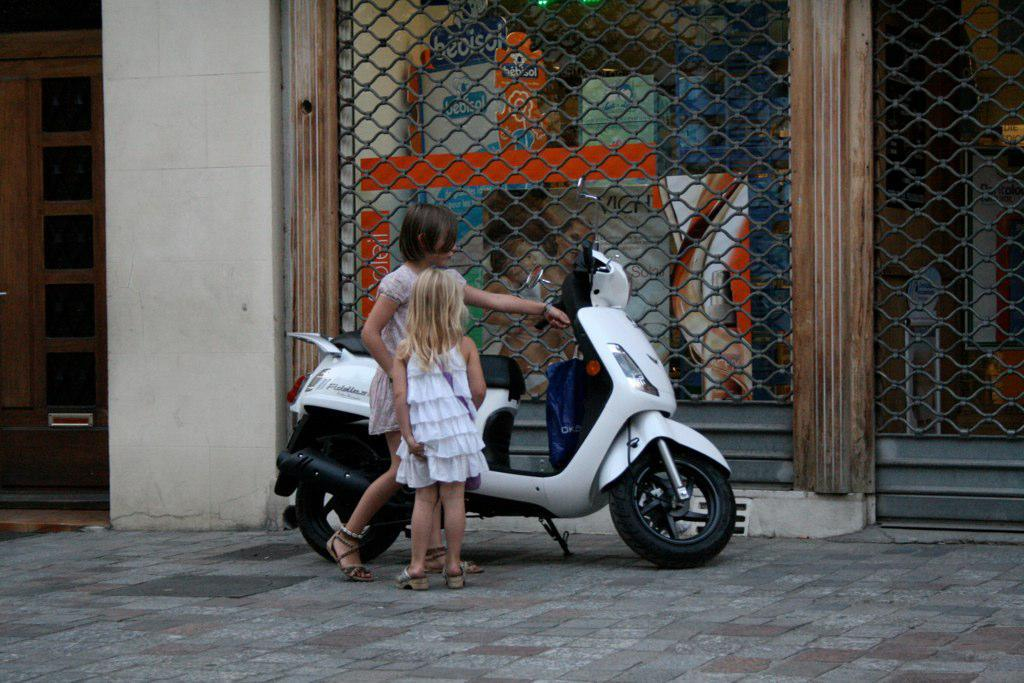What is the main subject of the image? There is a vehicle in the image. Can you describe the people in the image? There are two girls on the ground in the image. What can be seen in the background of the image? There is a poster visible in the background of the image. What type of prison can be seen in the image? There is no prison present in the image. What story are the girls telling each other in the image? The image does not provide any information about a story being told by the girls. 